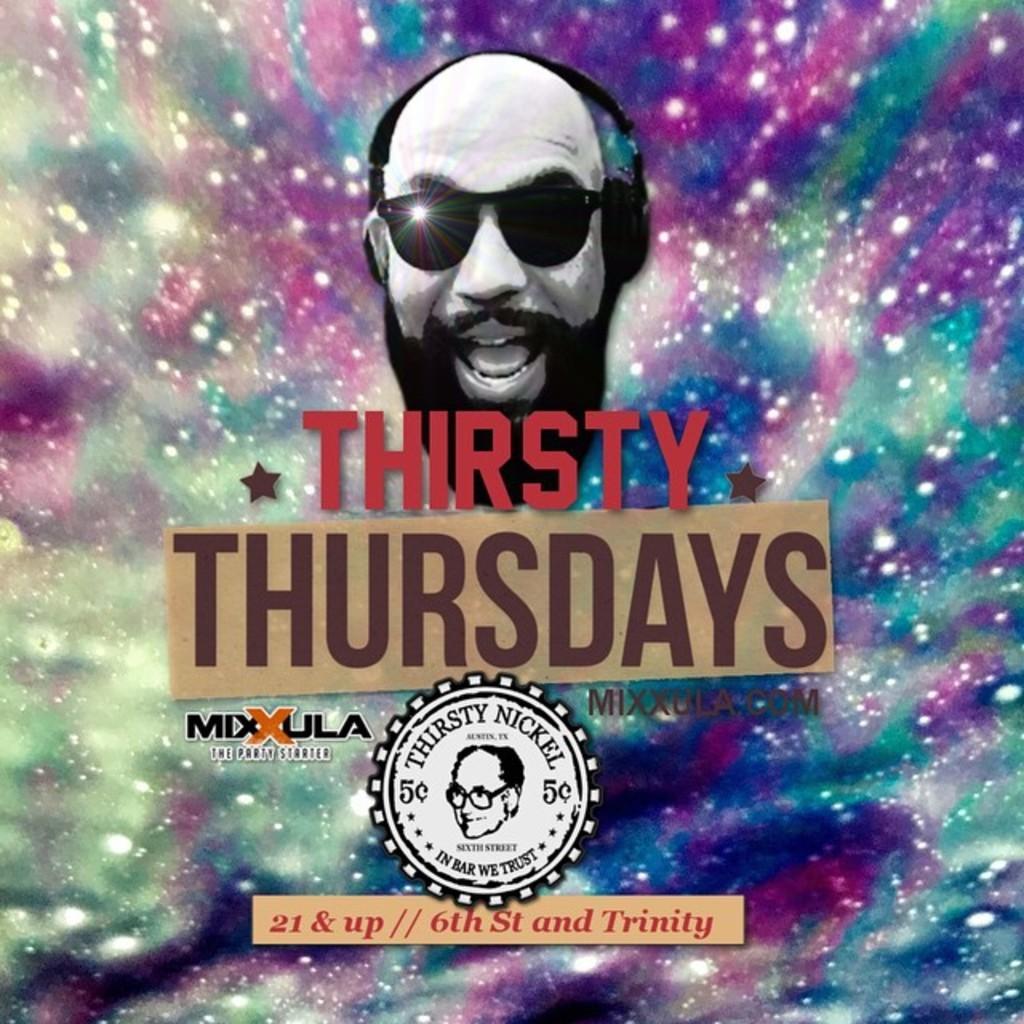In one or two sentences, can you explain what this image depicts? In this image I can see a poster on which I can see a human face wearing goggles. On the poster I can see a stamp in which I can see a human face. 